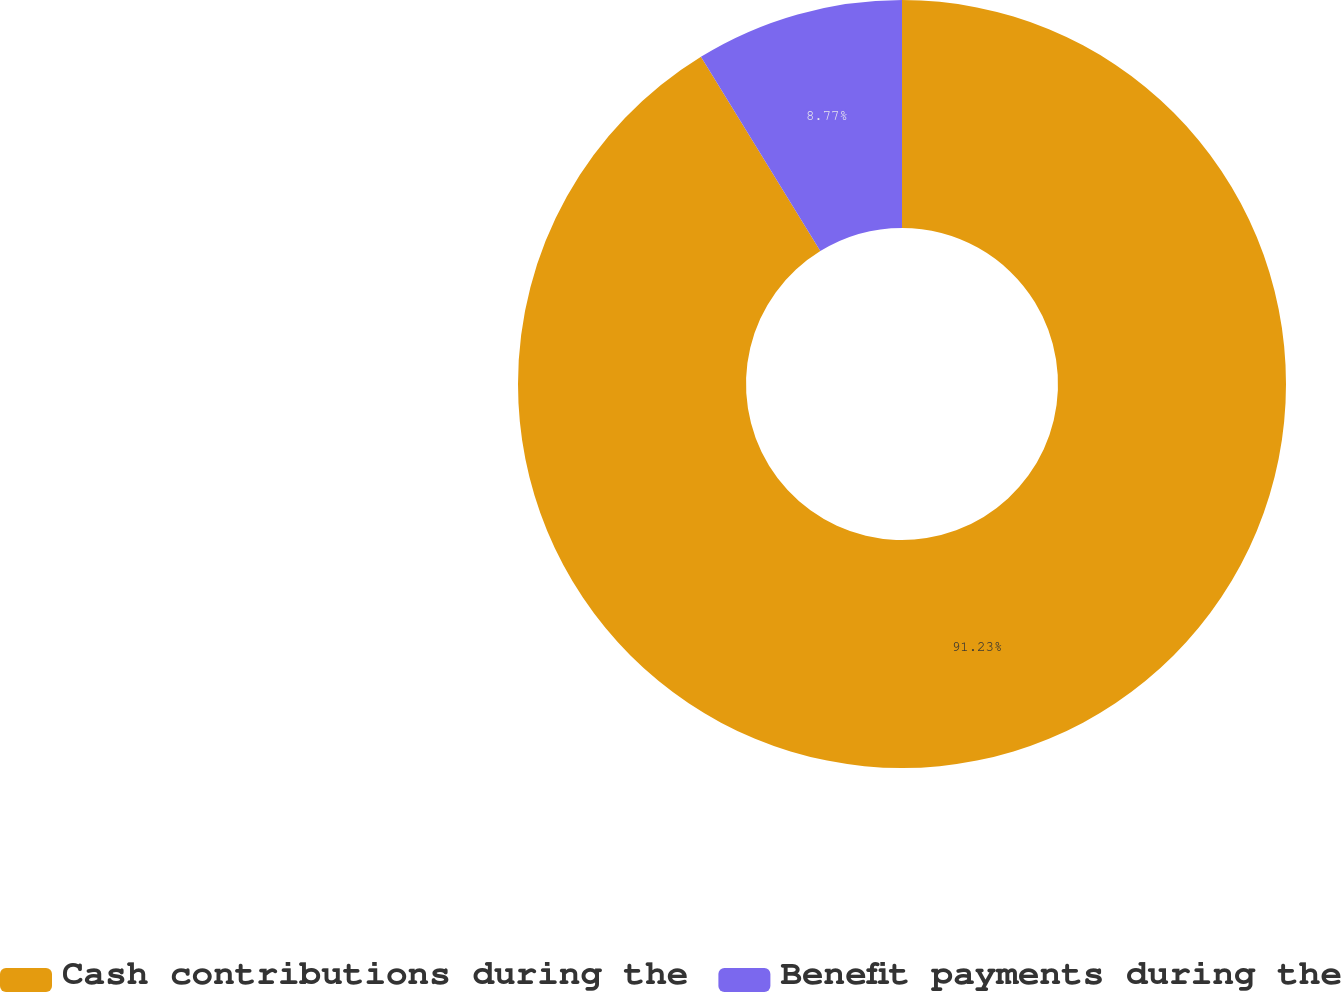Convert chart. <chart><loc_0><loc_0><loc_500><loc_500><pie_chart><fcel>Cash contributions during the<fcel>Benefit payments during the<nl><fcel>91.23%<fcel>8.77%<nl></chart> 